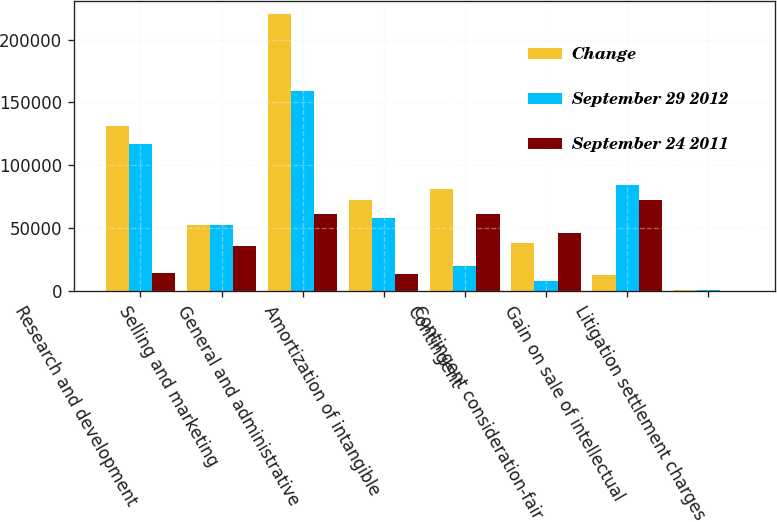Convert chart. <chart><loc_0><loc_0><loc_500><loc_500><stacked_bar_chart><ecel><fcel>Research and development<fcel>Selling and marketing<fcel>General and administrative<fcel>Amortization of intangible<fcel>Contingent<fcel>Contingent consideration-fair<fcel>Gain on sale of intellectual<fcel>Litigation settlement charges<nl><fcel>Change<fcel>130962<fcel>52408<fcel>220042<fcel>72036<fcel>81031<fcel>38466<fcel>12424<fcel>452<nl><fcel>September 29 2012<fcel>116696<fcel>52408<fcel>158793<fcel>58334<fcel>20002<fcel>8016<fcel>84502<fcel>770<nl><fcel>September 24 2011<fcel>14266<fcel>35584<fcel>61249<fcel>13702<fcel>61029<fcel>46482<fcel>72078<fcel>318<nl></chart> 